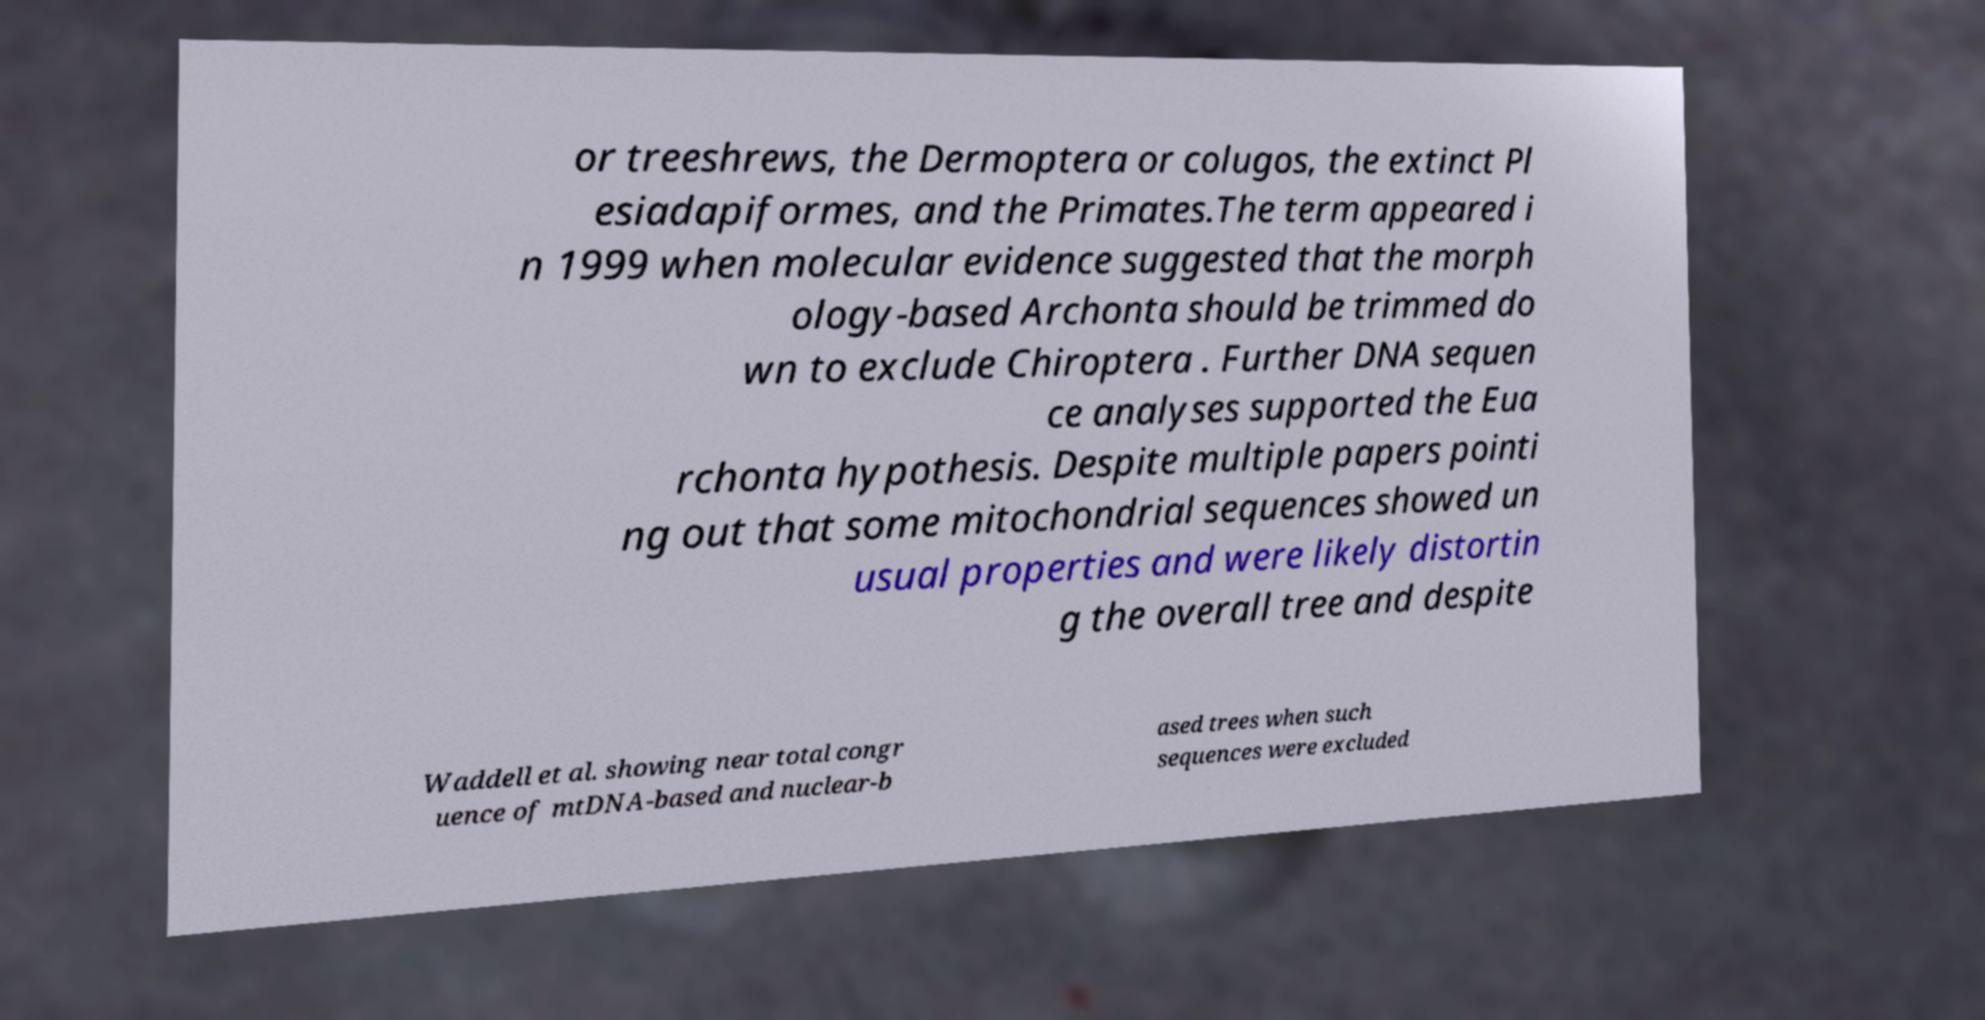For documentation purposes, I need the text within this image transcribed. Could you provide that? or treeshrews, the Dermoptera or colugos, the extinct Pl esiadapiformes, and the Primates.The term appeared i n 1999 when molecular evidence suggested that the morph ology-based Archonta should be trimmed do wn to exclude Chiroptera . Further DNA sequen ce analyses supported the Eua rchonta hypothesis. Despite multiple papers pointi ng out that some mitochondrial sequences showed un usual properties and were likely distortin g the overall tree and despite Waddell et al. showing near total congr uence of mtDNA-based and nuclear-b ased trees when such sequences were excluded 